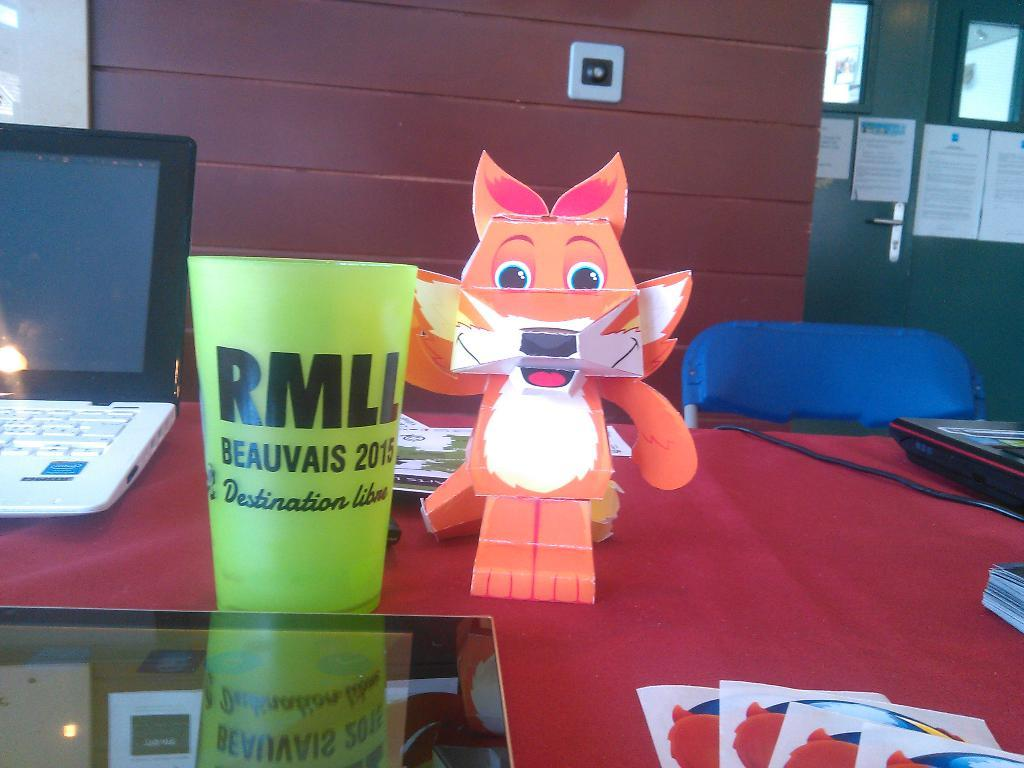What is the main piece of furniture in the image? There is a table in the image. What is covering the table? The table has a red cloth on it. What electronic device is on the table? There is a laptop on the table. What other objects can be seen on the table? There are other objects on the table. What is the name of the person using the laptop in the image? There is no person visible in the image, so we cannot determine the name of anyone using the laptop. 